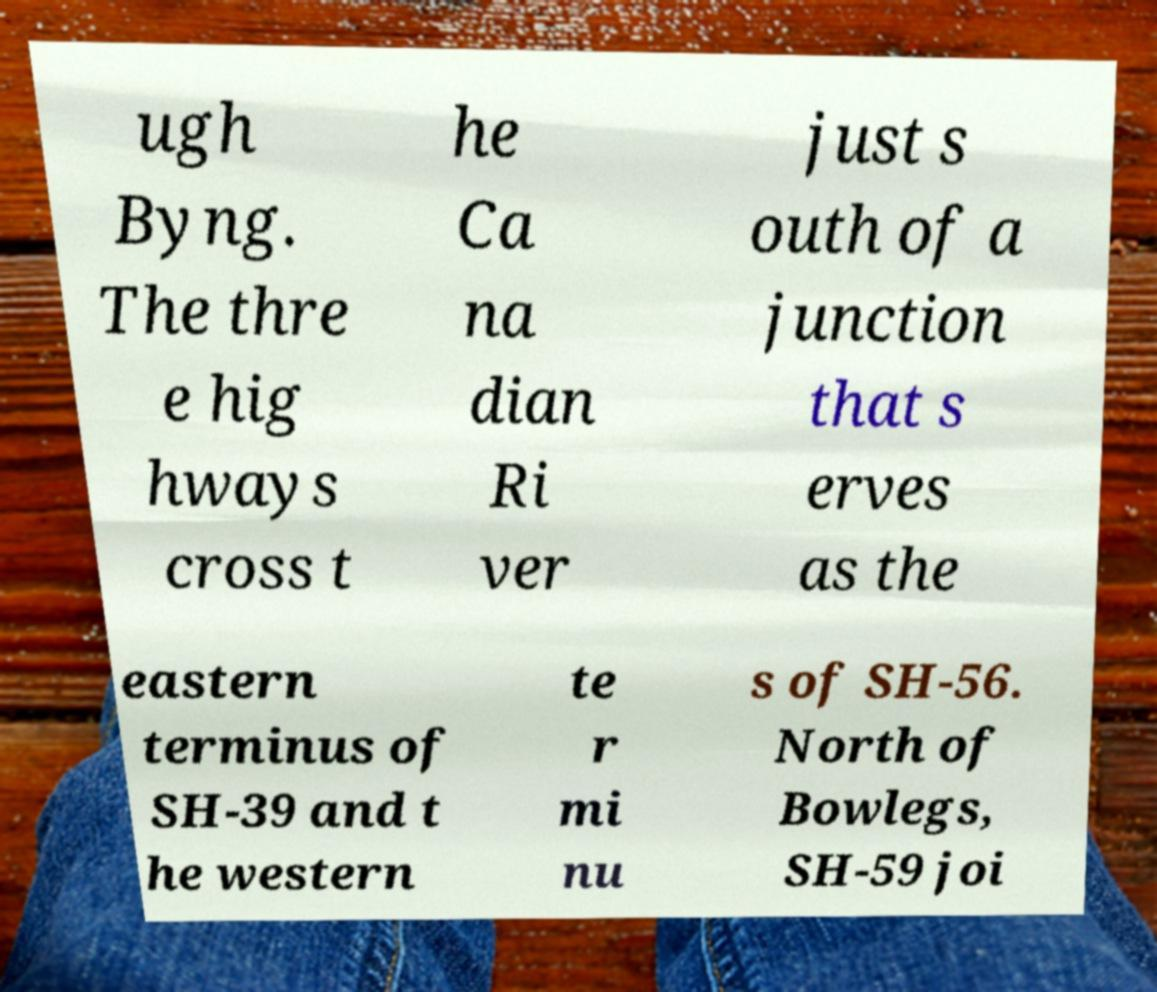Could you assist in decoding the text presented in this image and type it out clearly? ugh Byng. The thre e hig hways cross t he Ca na dian Ri ver just s outh of a junction that s erves as the eastern terminus of SH-39 and t he western te r mi nu s of SH-56. North of Bowlegs, SH-59 joi 